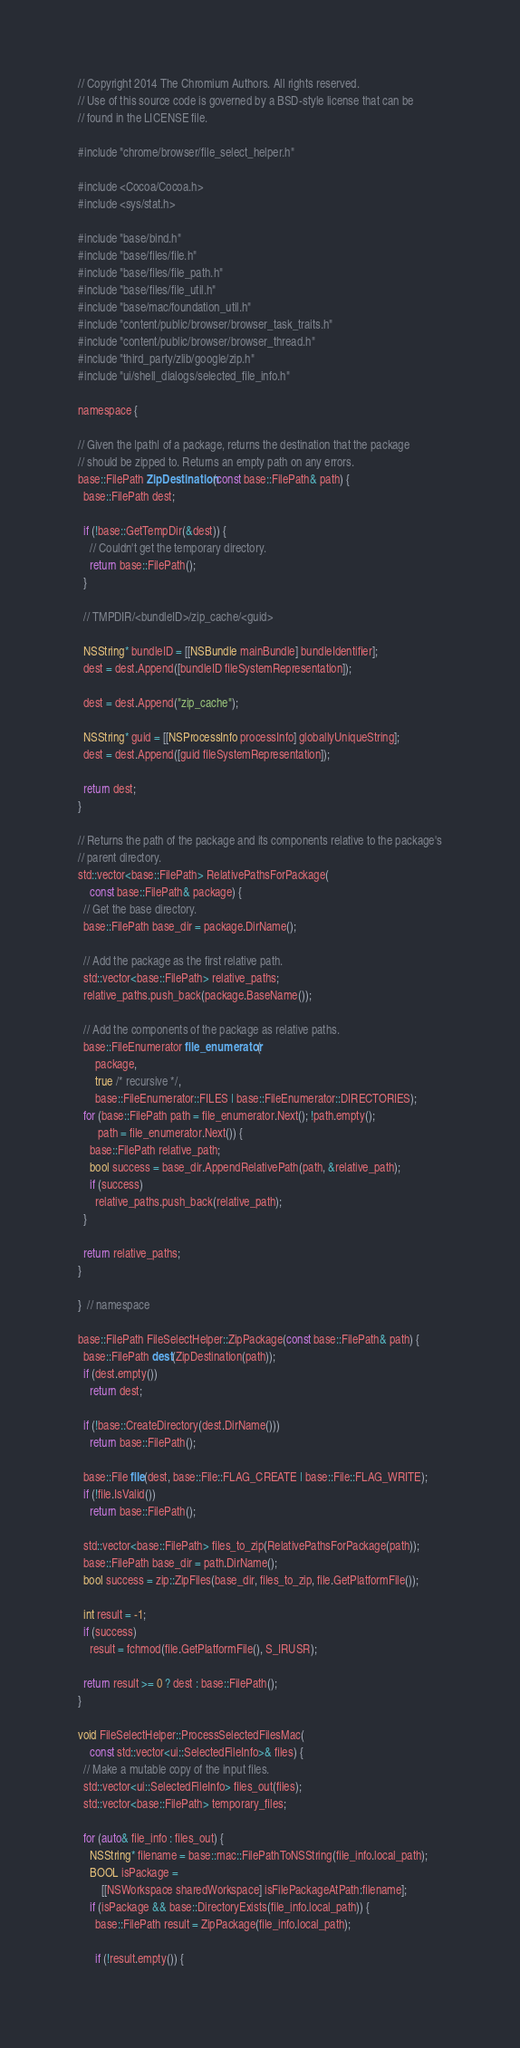<code> <loc_0><loc_0><loc_500><loc_500><_ObjectiveC_>// Copyright 2014 The Chromium Authors. All rights reserved.
// Use of this source code is governed by a BSD-style license that can be
// found in the LICENSE file.

#include "chrome/browser/file_select_helper.h"

#include <Cocoa/Cocoa.h>
#include <sys/stat.h>

#include "base/bind.h"
#include "base/files/file.h"
#include "base/files/file_path.h"
#include "base/files/file_util.h"
#include "base/mac/foundation_util.h"
#include "content/public/browser/browser_task_traits.h"
#include "content/public/browser/browser_thread.h"
#include "third_party/zlib/google/zip.h"
#include "ui/shell_dialogs/selected_file_info.h"

namespace {

// Given the |path| of a package, returns the destination that the package
// should be zipped to. Returns an empty path on any errors.
base::FilePath ZipDestination(const base::FilePath& path) {
  base::FilePath dest;

  if (!base::GetTempDir(&dest)) {
    // Couldn't get the temporary directory.
    return base::FilePath();
  }

  // TMPDIR/<bundleID>/zip_cache/<guid>

  NSString* bundleID = [[NSBundle mainBundle] bundleIdentifier];
  dest = dest.Append([bundleID fileSystemRepresentation]);

  dest = dest.Append("zip_cache");

  NSString* guid = [[NSProcessInfo processInfo] globallyUniqueString];
  dest = dest.Append([guid fileSystemRepresentation]);

  return dest;
}

// Returns the path of the package and its components relative to the package's
// parent directory.
std::vector<base::FilePath> RelativePathsForPackage(
    const base::FilePath& package) {
  // Get the base directory.
  base::FilePath base_dir = package.DirName();

  // Add the package as the first relative path.
  std::vector<base::FilePath> relative_paths;
  relative_paths.push_back(package.BaseName());

  // Add the components of the package as relative paths.
  base::FileEnumerator file_enumerator(
      package,
      true /* recursive */,
      base::FileEnumerator::FILES | base::FileEnumerator::DIRECTORIES);
  for (base::FilePath path = file_enumerator.Next(); !path.empty();
       path = file_enumerator.Next()) {
    base::FilePath relative_path;
    bool success = base_dir.AppendRelativePath(path, &relative_path);
    if (success)
      relative_paths.push_back(relative_path);
  }

  return relative_paths;
}

}  // namespace

base::FilePath FileSelectHelper::ZipPackage(const base::FilePath& path) {
  base::FilePath dest(ZipDestination(path));
  if (dest.empty())
    return dest;

  if (!base::CreateDirectory(dest.DirName()))
    return base::FilePath();

  base::File file(dest, base::File::FLAG_CREATE | base::File::FLAG_WRITE);
  if (!file.IsValid())
    return base::FilePath();

  std::vector<base::FilePath> files_to_zip(RelativePathsForPackage(path));
  base::FilePath base_dir = path.DirName();
  bool success = zip::ZipFiles(base_dir, files_to_zip, file.GetPlatformFile());

  int result = -1;
  if (success)
    result = fchmod(file.GetPlatformFile(), S_IRUSR);

  return result >= 0 ? dest : base::FilePath();
}

void FileSelectHelper::ProcessSelectedFilesMac(
    const std::vector<ui::SelectedFileInfo>& files) {
  // Make a mutable copy of the input files.
  std::vector<ui::SelectedFileInfo> files_out(files);
  std::vector<base::FilePath> temporary_files;

  for (auto& file_info : files_out) {
    NSString* filename = base::mac::FilePathToNSString(file_info.local_path);
    BOOL isPackage =
        [[NSWorkspace sharedWorkspace] isFilePackageAtPath:filename];
    if (isPackage && base::DirectoryExists(file_info.local_path)) {
      base::FilePath result = ZipPackage(file_info.local_path);

      if (!result.empty()) {</code> 